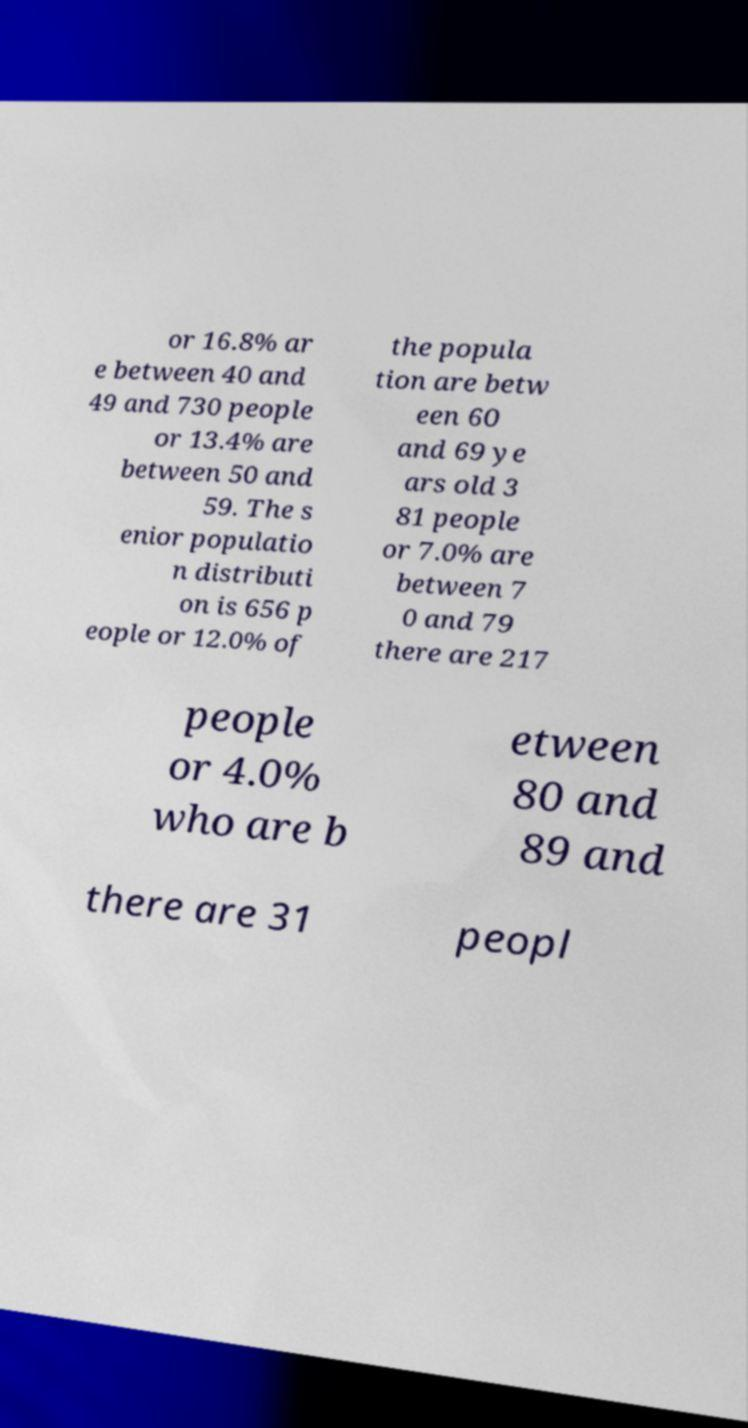Can you accurately transcribe the text from the provided image for me? or 16.8% ar e between 40 and 49 and 730 people or 13.4% are between 50 and 59. The s enior populatio n distributi on is 656 p eople or 12.0% of the popula tion are betw een 60 and 69 ye ars old 3 81 people or 7.0% are between 7 0 and 79 there are 217 people or 4.0% who are b etween 80 and 89 and there are 31 peopl 